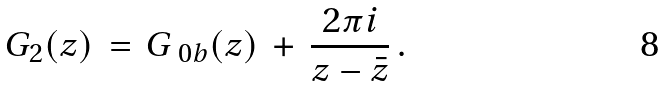Convert formula to latex. <formula><loc_0><loc_0><loc_500><loc_500>G _ { 2 } ( z ) \, = \, G _ { \ 0 b } ( z ) \, + \, \frac { 2 \pi i } { z - \bar { z } } \, .</formula> 